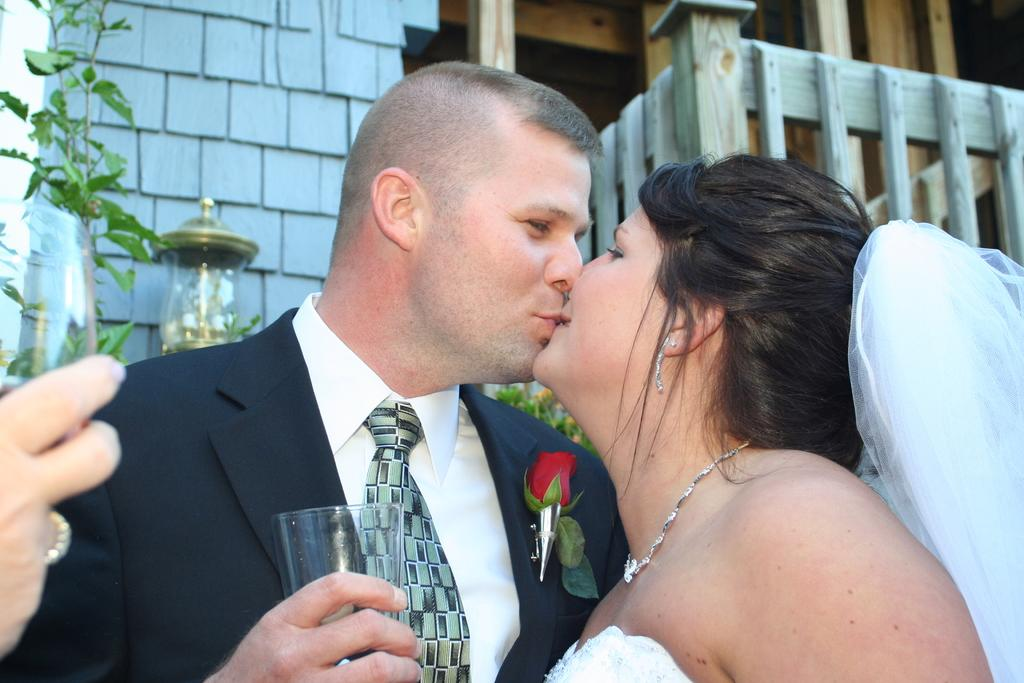How many people are in the image? There are two people in the image, a man and a woman. What are the man and woman doing in the image? The man and woman are kissing each other. What object can be seen in the image that might be used for drinking? There is a glass in the image. What type of barrier is visible in the image? There is a wooden fence in the image. What type of lighting fixture is present in the image? There is a lamp in the image. What type of yoke is being used to push the vessel in the image? There is no yoke, vessel, or pushing action present in the image. 